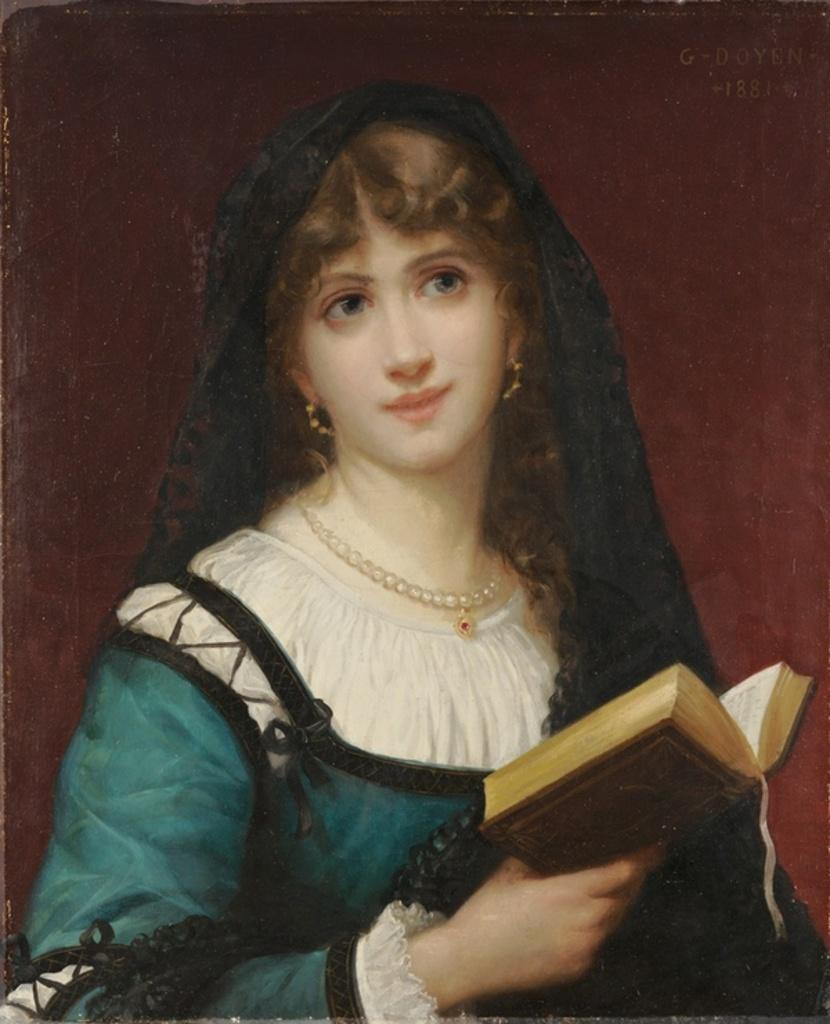What is depicted in the painting in the image? There is a painting of a woman in the image. What is the woman holding in the painting? The woman is holding a book in the painting. What can be seen behind the woman in the painting? There is a wall behind the woman in the painting. What type of cake is on the hill in the image? There is no cake or hill present in the image; it features a painting of a woman holding a book. 